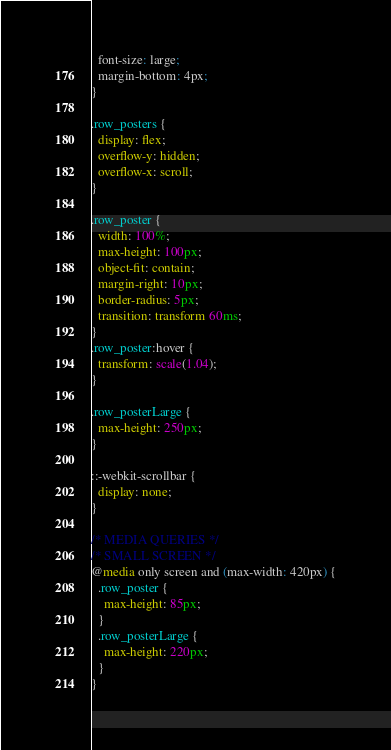Convert code to text. <code><loc_0><loc_0><loc_500><loc_500><_CSS_>  font-size: large;
  margin-bottom: 4px;
}

.row_posters {
  display: flex;
  overflow-y: hidden;
  overflow-x: scroll;
}

.row_poster {
  width: 100%;
  max-height: 100px;
  object-fit: contain;
  margin-right: 10px;
  border-radius: 5px;
  transition: transform 60ms;
}
.row_poster:hover {
  transform: scale(1.04);
}

.row_posterLarge {
  max-height: 250px;
}

::-webkit-scrollbar {
  display: none;
}

/* MEDIA QUERIES */
/* SMALL SCREEN */
@media only screen and (max-width: 420px) {
  .row_poster {
    max-height: 85px;
  }
  .row_posterLarge {
    max-height: 220px;
  }
}
</code> 